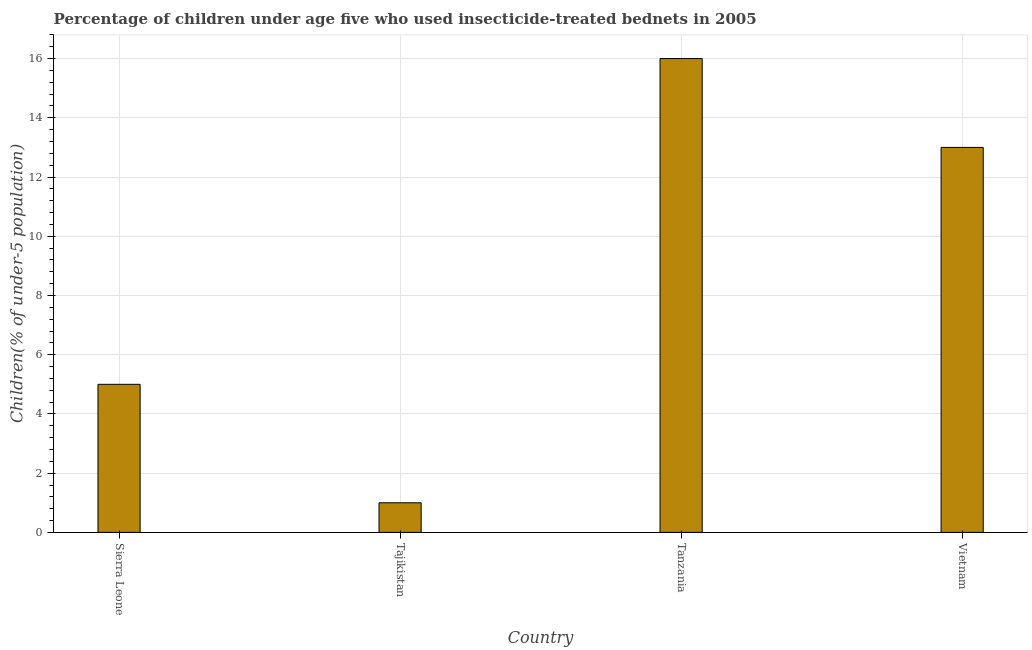What is the title of the graph?
Ensure brevity in your answer.  Percentage of children under age five who used insecticide-treated bednets in 2005. What is the label or title of the Y-axis?
Offer a very short reply. Children(% of under-5 population). What is the percentage of children who use of insecticide-treated bed nets in Tajikistan?
Give a very brief answer. 1. Across all countries, what is the maximum percentage of children who use of insecticide-treated bed nets?
Offer a terse response. 16. Across all countries, what is the minimum percentage of children who use of insecticide-treated bed nets?
Your response must be concise. 1. In which country was the percentage of children who use of insecticide-treated bed nets maximum?
Offer a terse response. Tanzania. In which country was the percentage of children who use of insecticide-treated bed nets minimum?
Keep it short and to the point. Tajikistan. What is the sum of the percentage of children who use of insecticide-treated bed nets?
Keep it short and to the point. 35. What is the median percentage of children who use of insecticide-treated bed nets?
Keep it short and to the point. 9. In how many countries, is the percentage of children who use of insecticide-treated bed nets greater than 5.2 %?
Your response must be concise. 2. What is the ratio of the percentage of children who use of insecticide-treated bed nets in Sierra Leone to that in Tanzania?
Keep it short and to the point. 0.31. Is the difference between the percentage of children who use of insecticide-treated bed nets in Sierra Leone and Vietnam greater than the difference between any two countries?
Provide a short and direct response. No. Is the sum of the percentage of children who use of insecticide-treated bed nets in Sierra Leone and Tajikistan greater than the maximum percentage of children who use of insecticide-treated bed nets across all countries?
Your answer should be compact. No. What is the difference between the highest and the lowest percentage of children who use of insecticide-treated bed nets?
Provide a succinct answer. 15. In how many countries, is the percentage of children who use of insecticide-treated bed nets greater than the average percentage of children who use of insecticide-treated bed nets taken over all countries?
Your answer should be very brief. 2. Are all the bars in the graph horizontal?
Provide a succinct answer. No. How many countries are there in the graph?
Provide a succinct answer. 4. What is the difference between the Children(% of under-5 population) in Sierra Leone and Tanzania?
Keep it short and to the point. -11. What is the difference between the Children(% of under-5 population) in Sierra Leone and Vietnam?
Keep it short and to the point. -8. What is the ratio of the Children(% of under-5 population) in Sierra Leone to that in Tajikistan?
Ensure brevity in your answer.  5. What is the ratio of the Children(% of under-5 population) in Sierra Leone to that in Tanzania?
Your answer should be compact. 0.31. What is the ratio of the Children(% of under-5 population) in Sierra Leone to that in Vietnam?
Give a very brief answer. 0.39. What is the ratio of the Children(% of under-5 population) in Tajikistan to that in Tanzania?
Your answer should be compact. 0.06. What is the ratio of the Children(% of under-5 population) in Tajikistan to that in Vietnam?
Your response must be concise. 0.08. What is the ratio of the Children(% of under-5 population) in Tanzania to that in Vietnam?
Give a very brief answer. 1.23. 